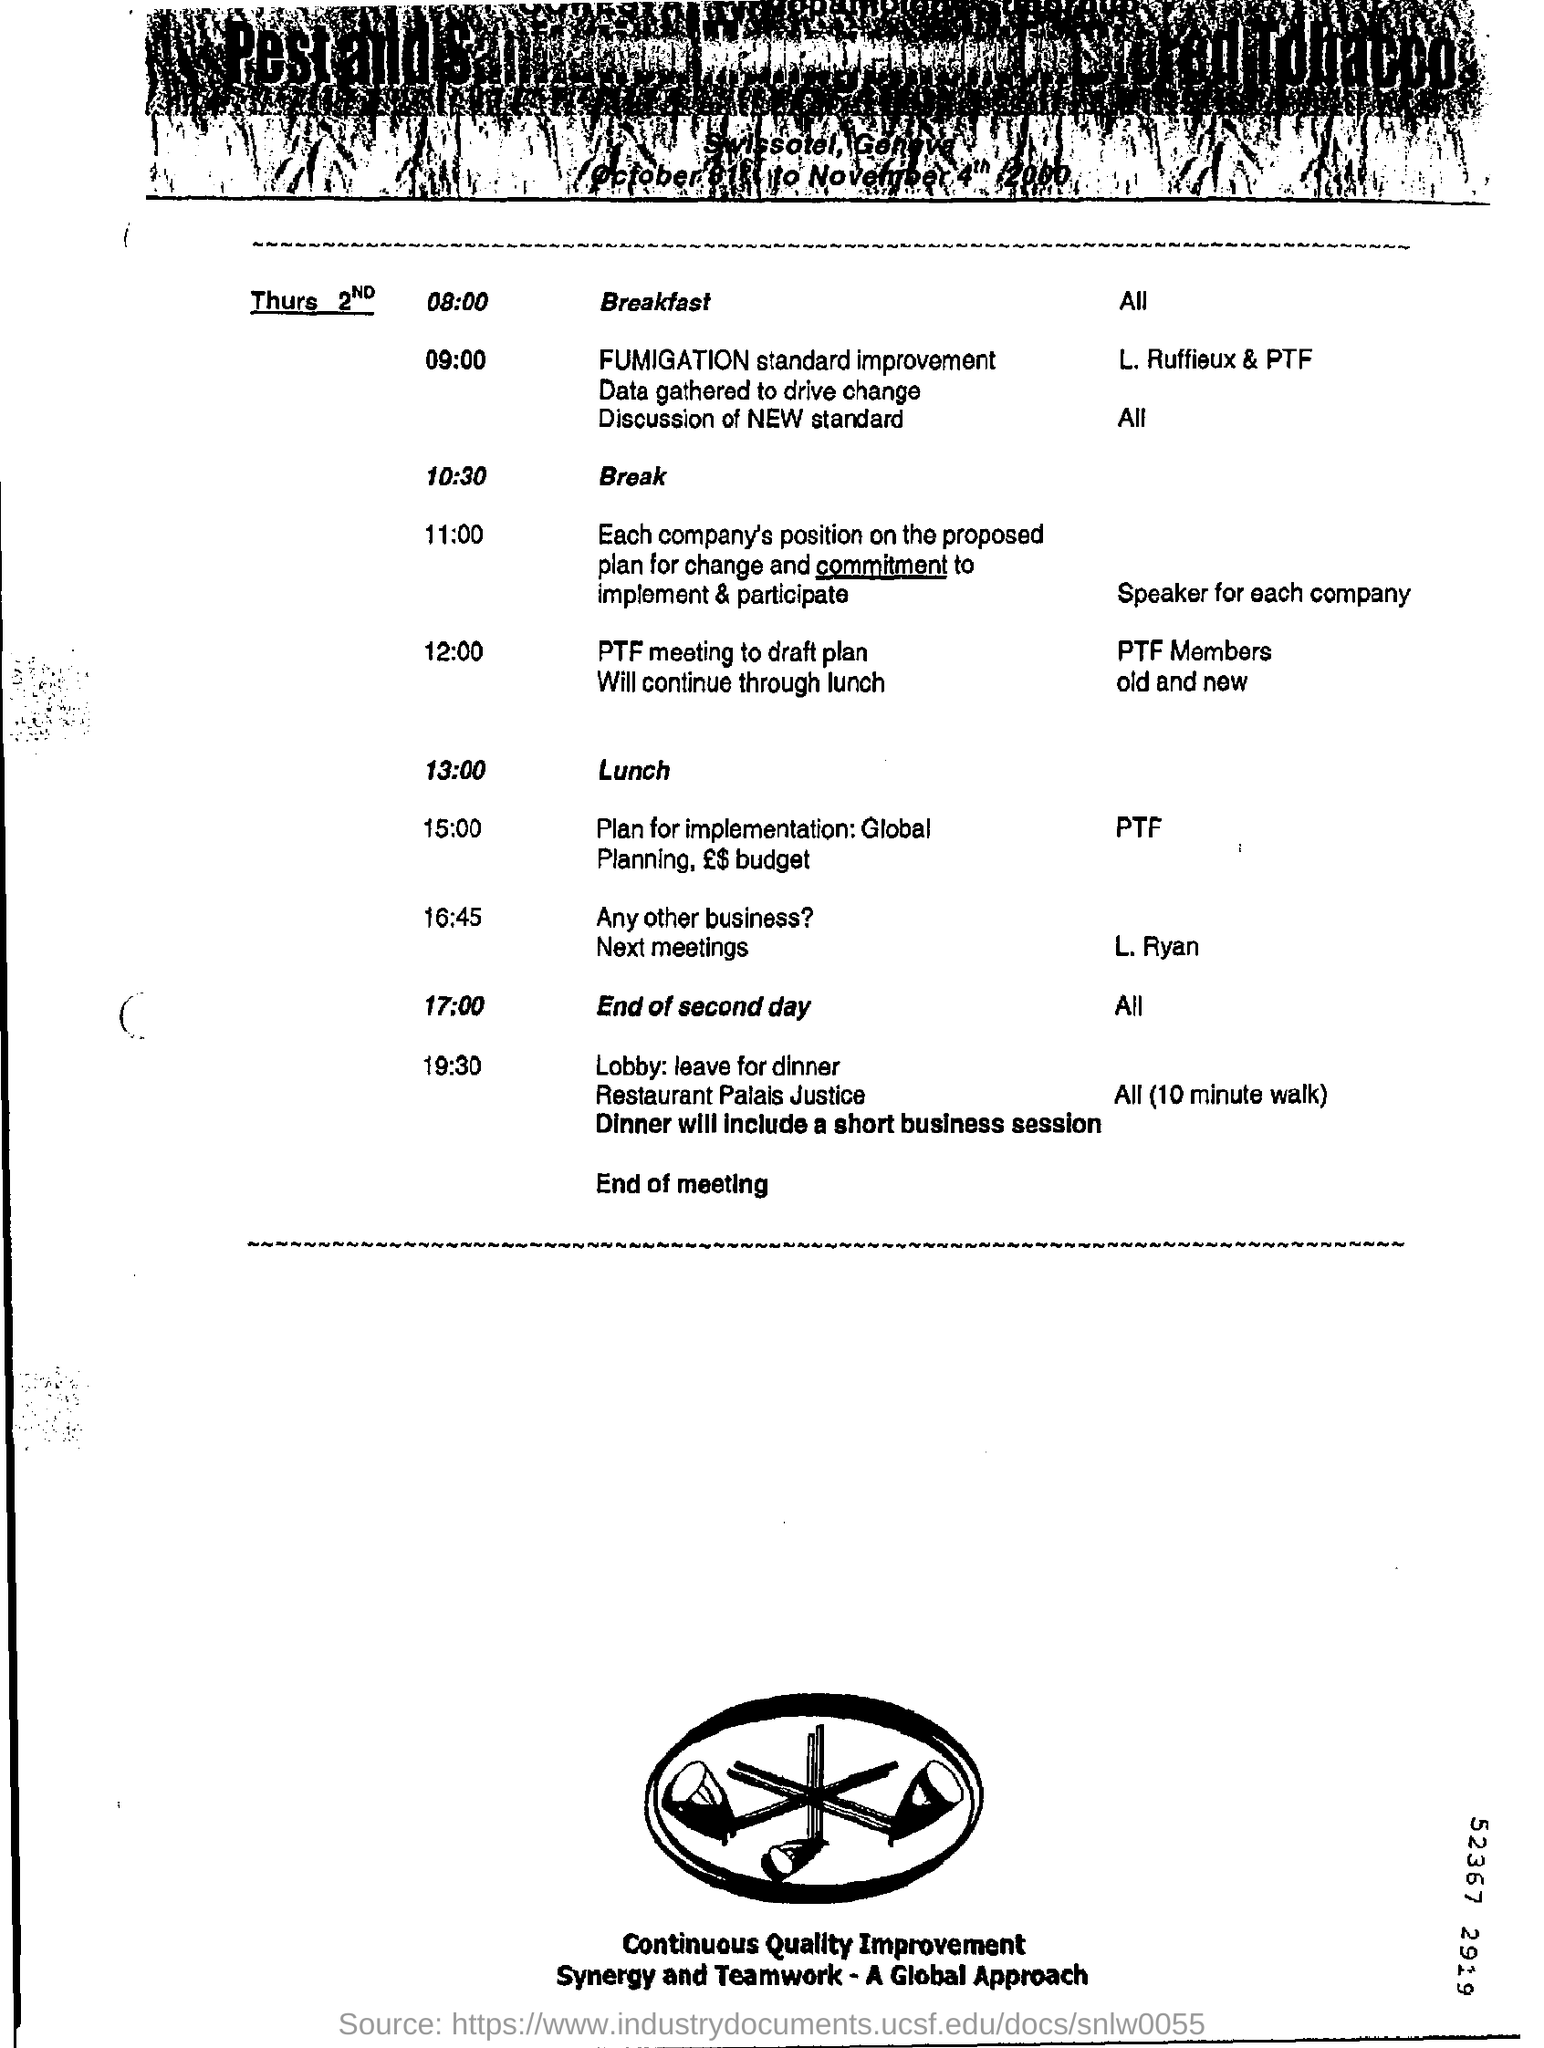When is the break?
Provide a succinct answer. 10:30. When is the lunch?
Your answer should be compact. 13:00. At what time second day ends?
Give a very brief answer. 17:00. 